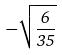Convert formula to latex. <formula><loc_0><loc_0><loc_500><loc_500>- \sqrt { \frac { 6 } { 3 5 } }</formula> 